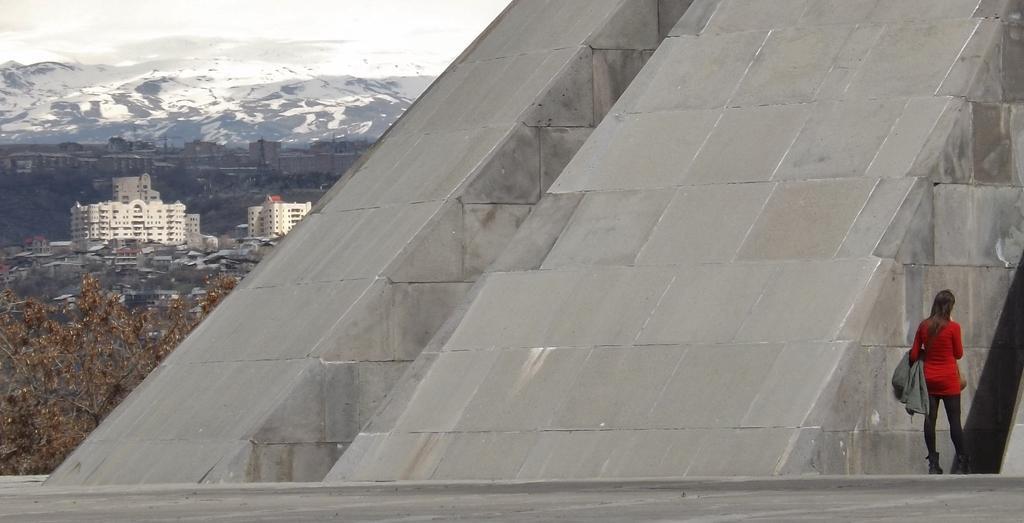In one or two sentences, can you explain what this image depicts? There is a woman wearing white dress is standing in the right corner and there is a sloped wall beside her and there are buildings and mountains covered with snow in the left corner. 